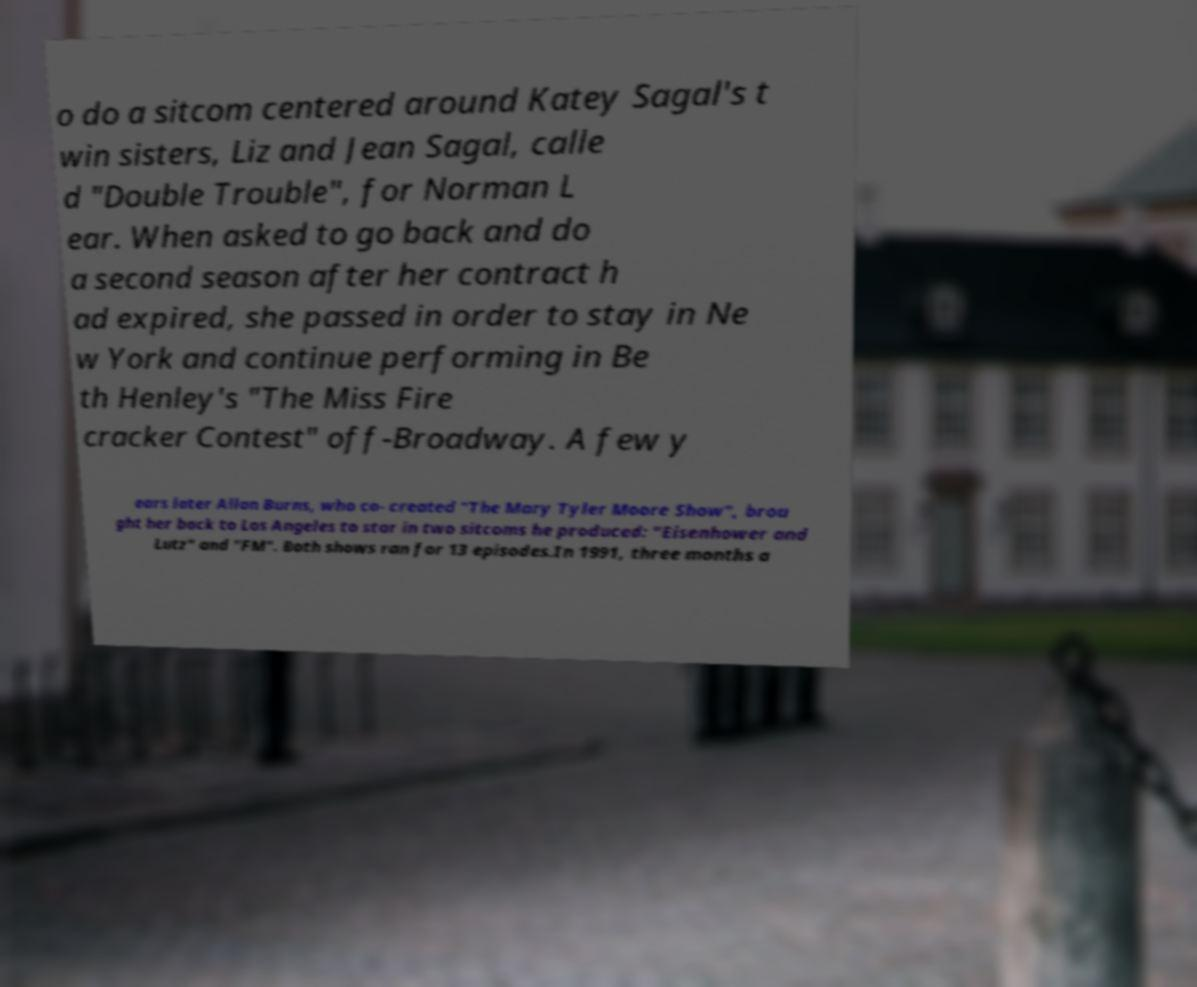Please read and relay the text visible in this image. What does it say? o do a sitcom centered around Katey Sagal's t win sisters, Liz and Jean Sagal, calle d "Double Trouble", for Norman L ear. When asked to go back and do a second season after her contract h ad expired, she passed in order to stay in Ne w York and continue performing in Be th Henley's "The Miss Fire cracker Contest" off-Broadway. A few y ears later Allan Burns, who co- created "The Mary Tyler Moore Show", brou ght her back to Los Angeles to star in two sitcoms he produced: "Eisenhower and Lutz" and "FM". Both shows ran for 13 episodes.In 1991, three months a 